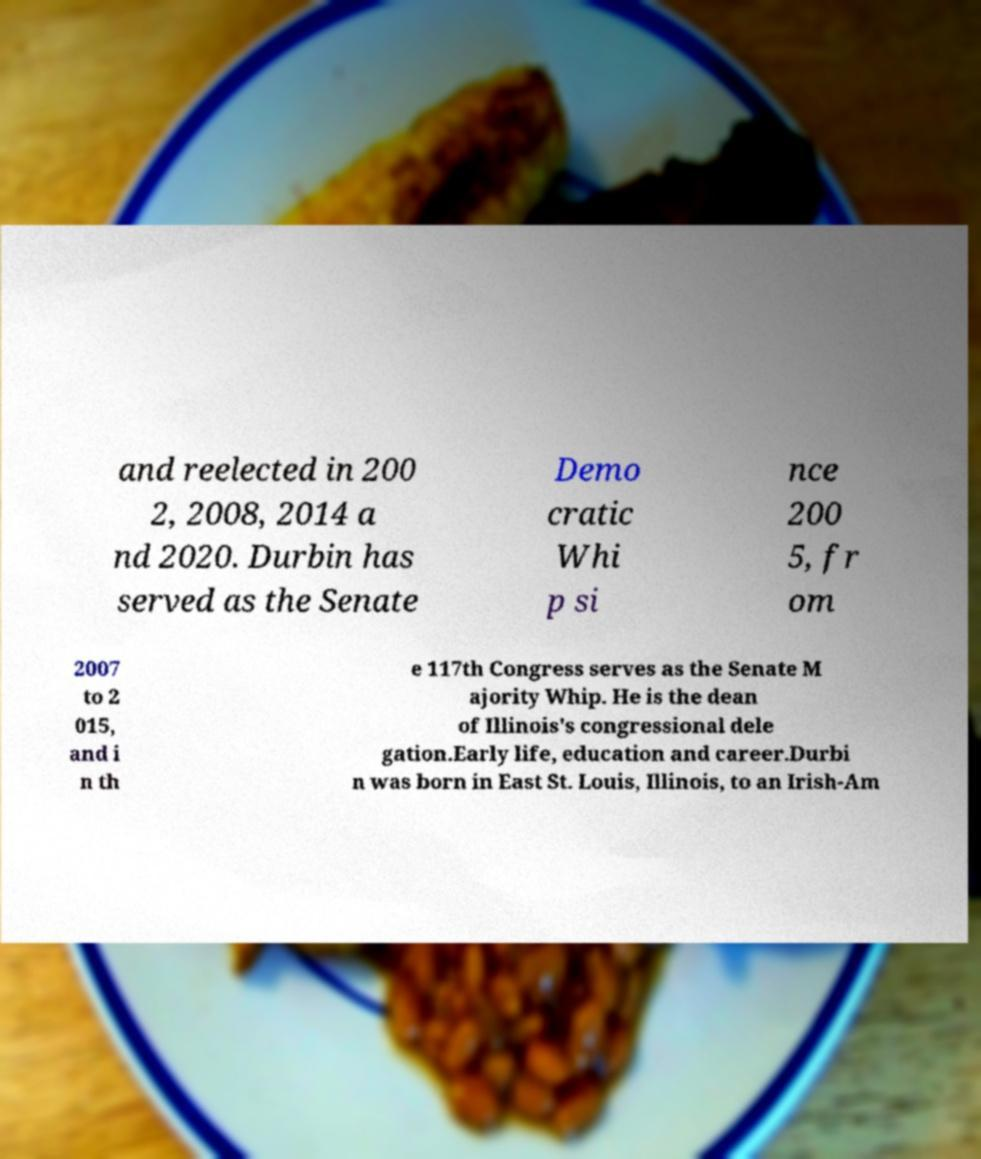Can you read and provide the text displayed in the image?This photo seems to have some interesting text. Can you extract and type it out for me? and reelected in 200 2, 2008, 2014 a nd 2020. Durbin has served as the Senate Demo cratic Whi p si nce 200 5, fr om 2007 to 2 015, and i n th e 117th Congress serves as the Senate M ajority Whip. He is the dean of Illinois's congressional dele gation.Early life, education and career.Durbi n was born in East St. Louis, Illinois, to an Irish-Am 